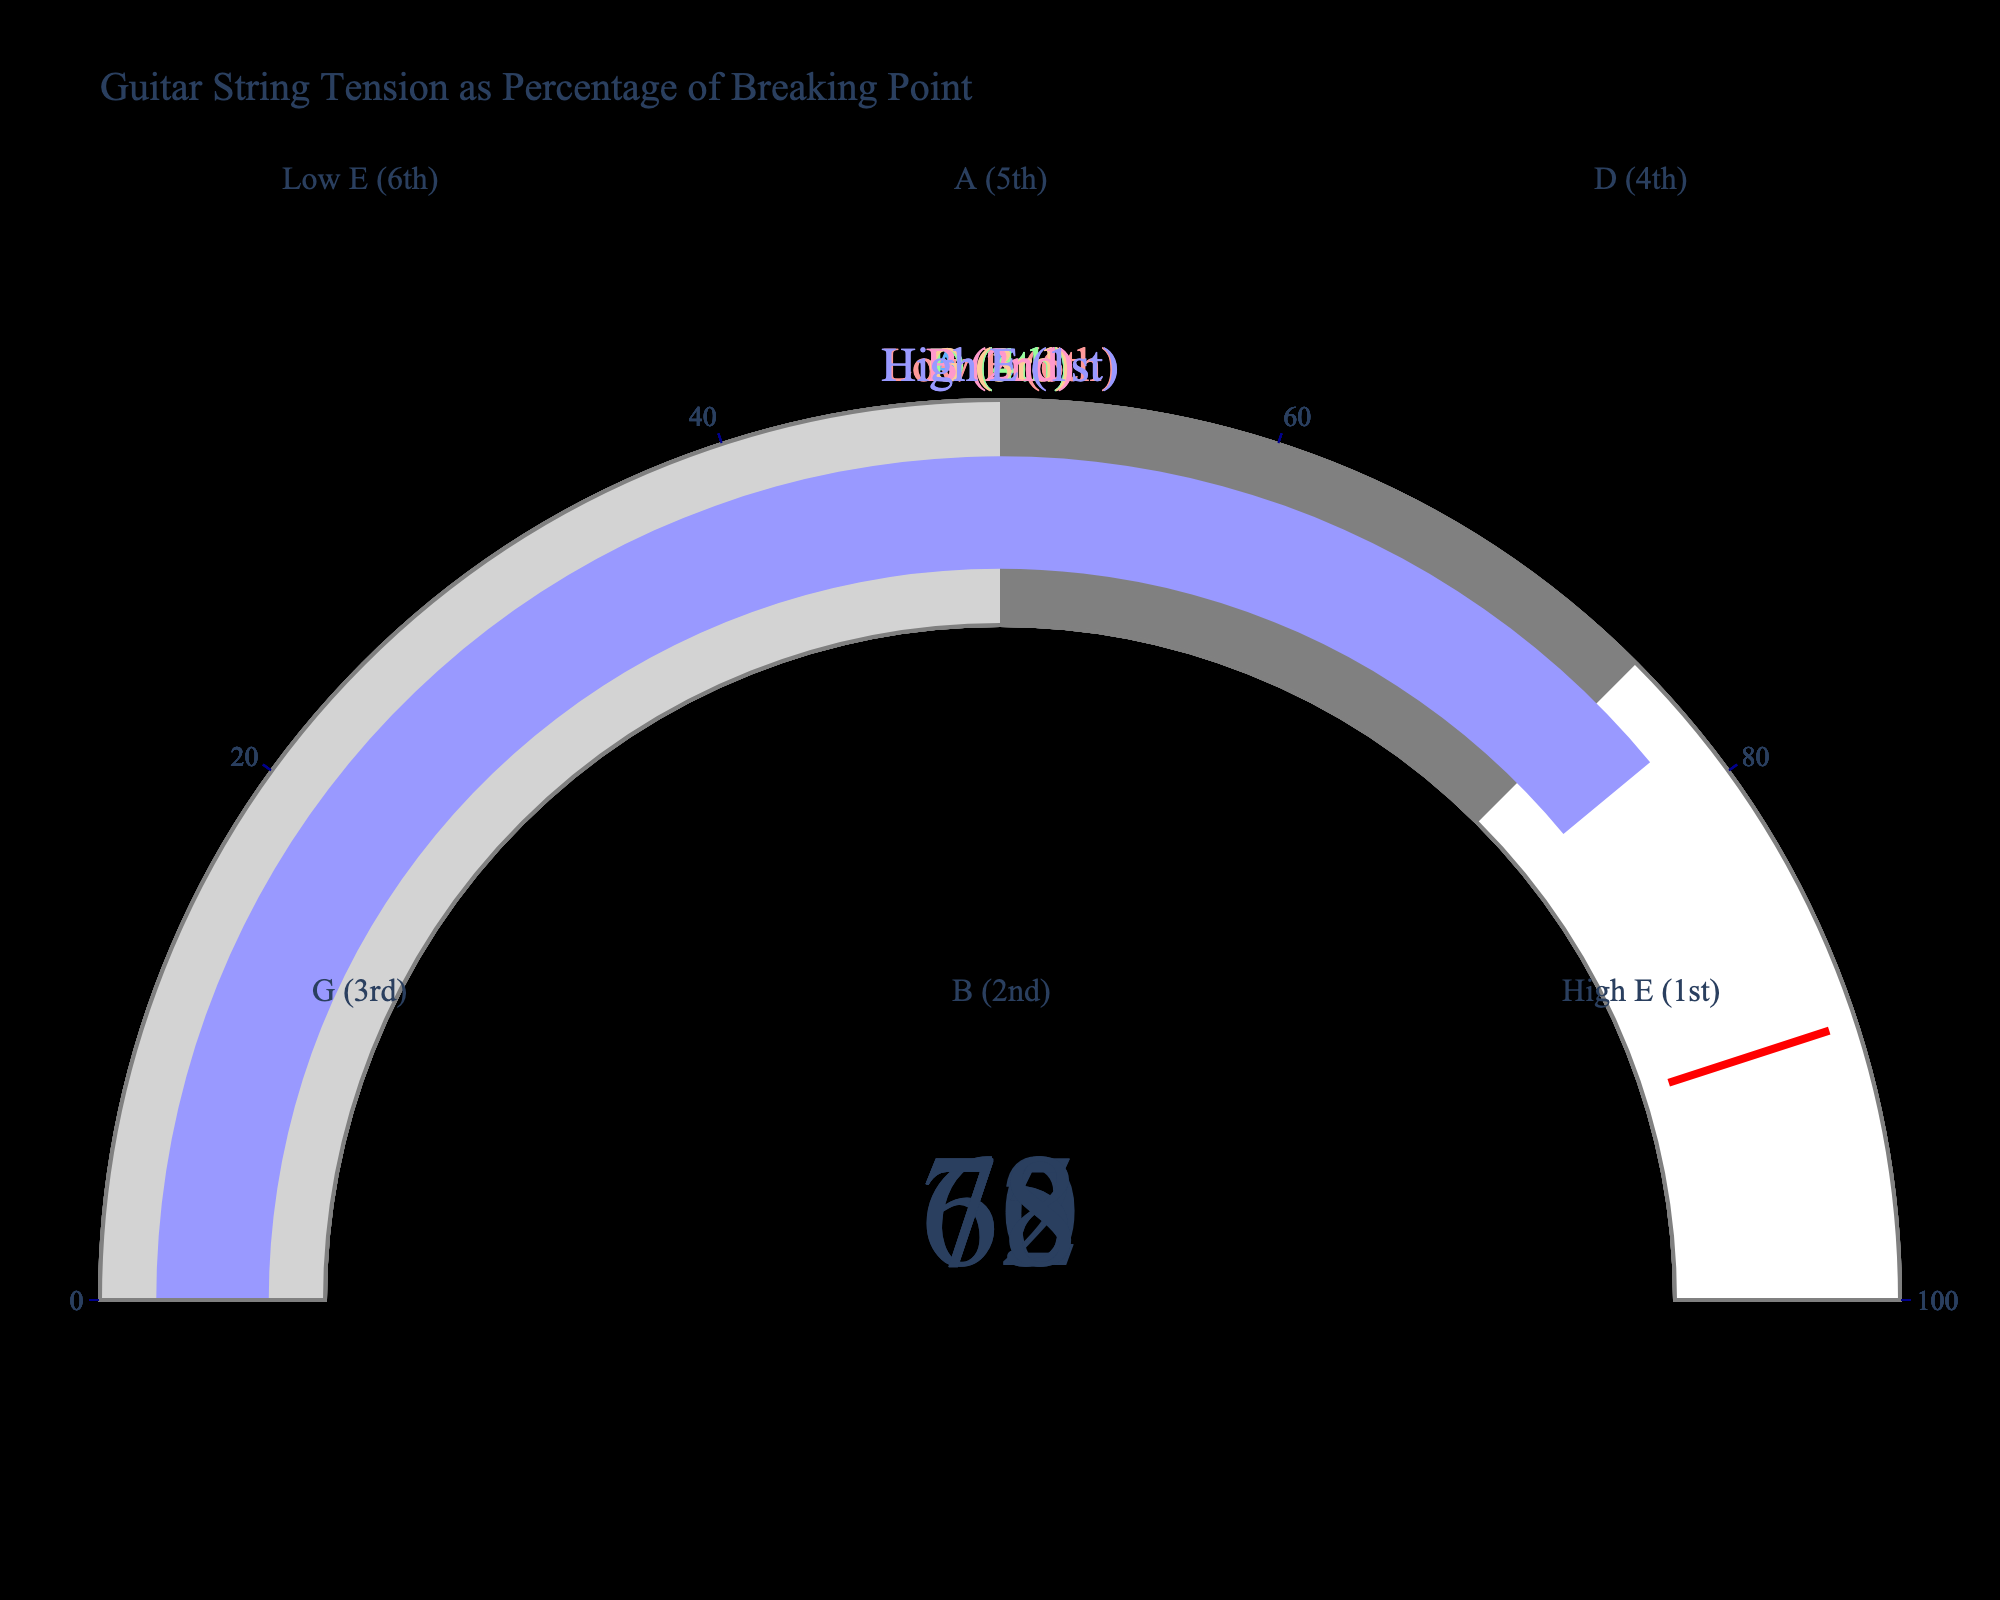Which guitar string shows the highest tension percentage? The string with the highest percentage can be found by directly comparing the gauge values in the figure. The High E (1st) string shows a tension percentage of 78.
Answer: High E (1st) How many guitar strings have their tension percentage below 70%? By inspecting the gauge values, we can count the strings with tension percentages below 70: Low E (6th) is 70%, A (5th) is 65%, and G (3rd) is 68%. Two are below 70%.
Answer: 2 What is the average tension percentage for all guitar strings? Sum the tension percentages for all strings (70 + 65 + 72 + 68 + 75 + 78) which equals 428, then divide by the number of strings, which is 6. The average is 428/6 ≈ 71.33.
Answer: 71.33 Which string has a lower tension percentage, the D (4th) or the G (3rd)? Compare the gauge values: D (4th) has 72%, while G (3rd) has 68%. G (3rd) is lower.
Answer: G (3rd) What is the total tension percentage for the A (5th) and B (2nd) strings combined? Add the values for A (5th) and B (2nd): 65 + 75 equals 140.
Answer: 140 Are any strings close to the threshold percentage of 90%? Examine the gauges to identify any values close to 90%. The highest value is High E (1st) at 78%, which is not close to 90%.
Answer: No What is the range of tension percentages among the guitar strings? Identify the highest and lowest values. The highest tension percentage is 78% (High E (1st)), and the lowest is 65% (A (5th)). The range is 78 - 65 = 13.
Answer: 13 Which string has a higher tension percentage, B (2nd) or Low E (6th)? Compare their gauge values: B (2nd) has 75%, Low E (6th) has 70%. B (2nd) is higher.
Answer: B (2nd) How does the tension percentage for G (3rd) compare to the average tension percentage? First, calculate the average tension percentage, which is approximately 71.33. G (3rd) has 68%, which is slightly below the average.
Answer: Below What is the difference in tension percentage between the highest and the lowest tensioned strings? Identify the highest and lowest tension percentages: Highest is High E (1st) at 78%, and lowest is A (5th) at 65%. The difference is 78 - 65 = 13.
Answer: 13 